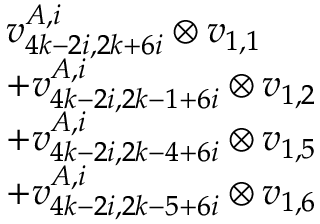<formula> <loc_0><loc_0><loc_500><loc_500>\begin{array} { r l } & { v _ { 4 k - 2 i , 2 k + 6 i } ^ { A , i } \otimes v _ { 1 , 1 } } \\ & { + v _ { 4 k - 2 i , 2 k - 1 + 6 i } ^ { A , i } \otimes v _ { 1 , 2 } } \\ & { + v _ { 4 k - 2 i , 2 k - 4 + 6 i } ^ { A , i } \otimes v _ { 1 , 5 } } \\ & { + v _ { 4 k - 2 i , 2 k - 5 + 6 i } ^ { A , i } \otimes v _ { 1 , 6 } } \end{array}</formula> 